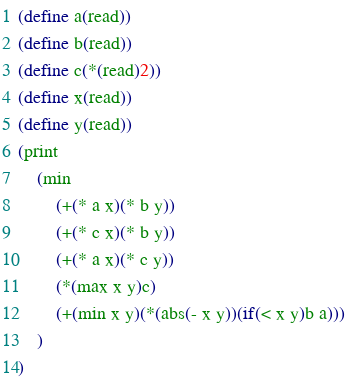Convert code to text. <code><loc_0><loc_0><loc_500><loc_500><_Scheme_>(define a(read))
(define b(read))
(define c(*(read)2))
(define x(read))
(define y(read))
(print
	(min
		(+(* a x)(* b y))
		(+(* c x)(* b y))
		(+(* a x)(* c y))
		(*(max x y)c)
		(+(min x y)(*(abs(- x y))(if(< x y)b a)))
	)
)</code> 